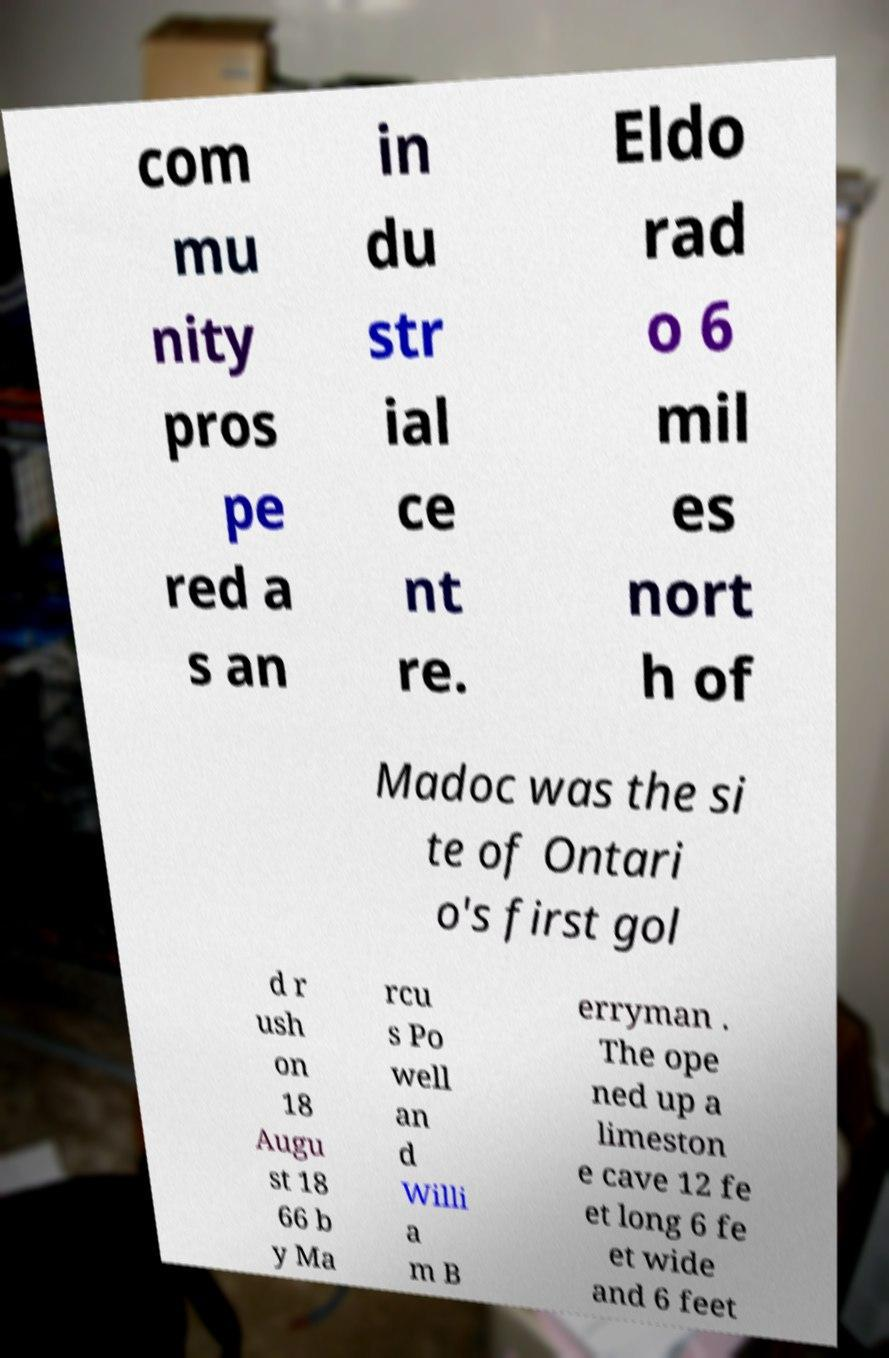Please read and relay the text visible in this image. What does it say? com mu nity pros pe red a s an in du str ial ce nt re. Eldo rad o 6 mil es nort h of Madoc was the si te of Ontari o's first gol d r ush on 18 Augu st 18 66 b y Ma rcu s Po well an d Willi a m B erryman . The ope ned up a limeston e cave 12 fe et long 6 fe et wide and 6 feet 